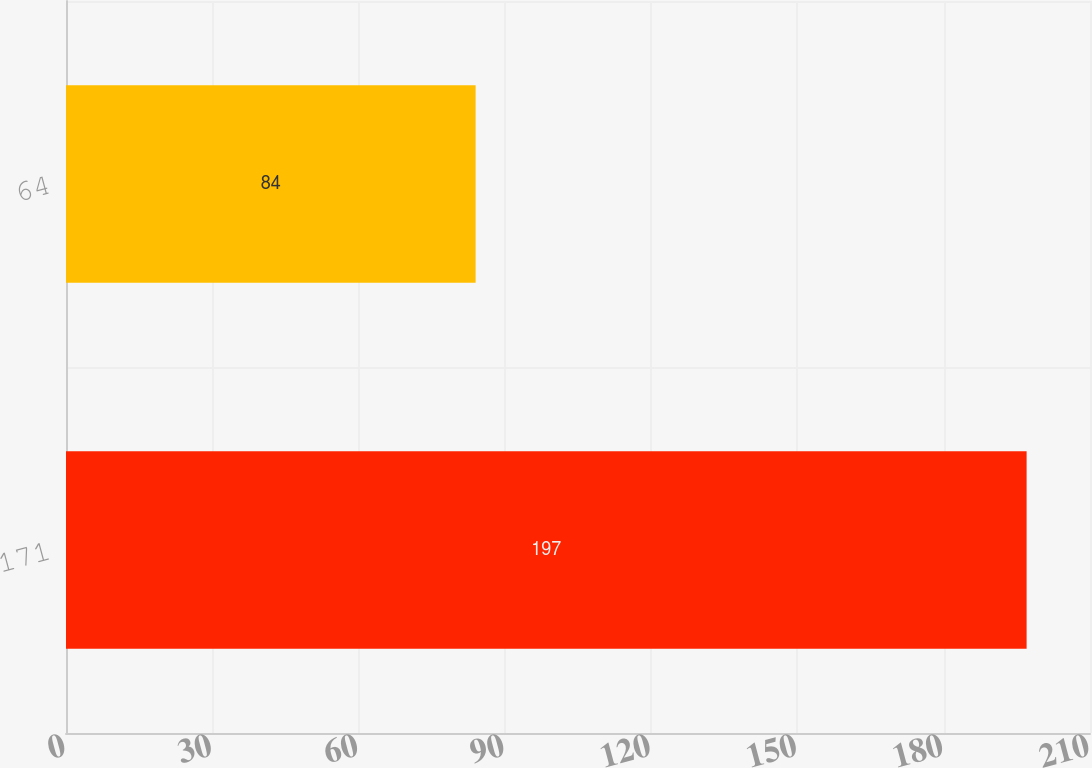Convert chart to OTSL. <chart><loc_0><loc_0><loc_500><loc_500><bar_chart><fcel>171<fcel>64<nl><fcel>197<fcel>84<nl></chart> 